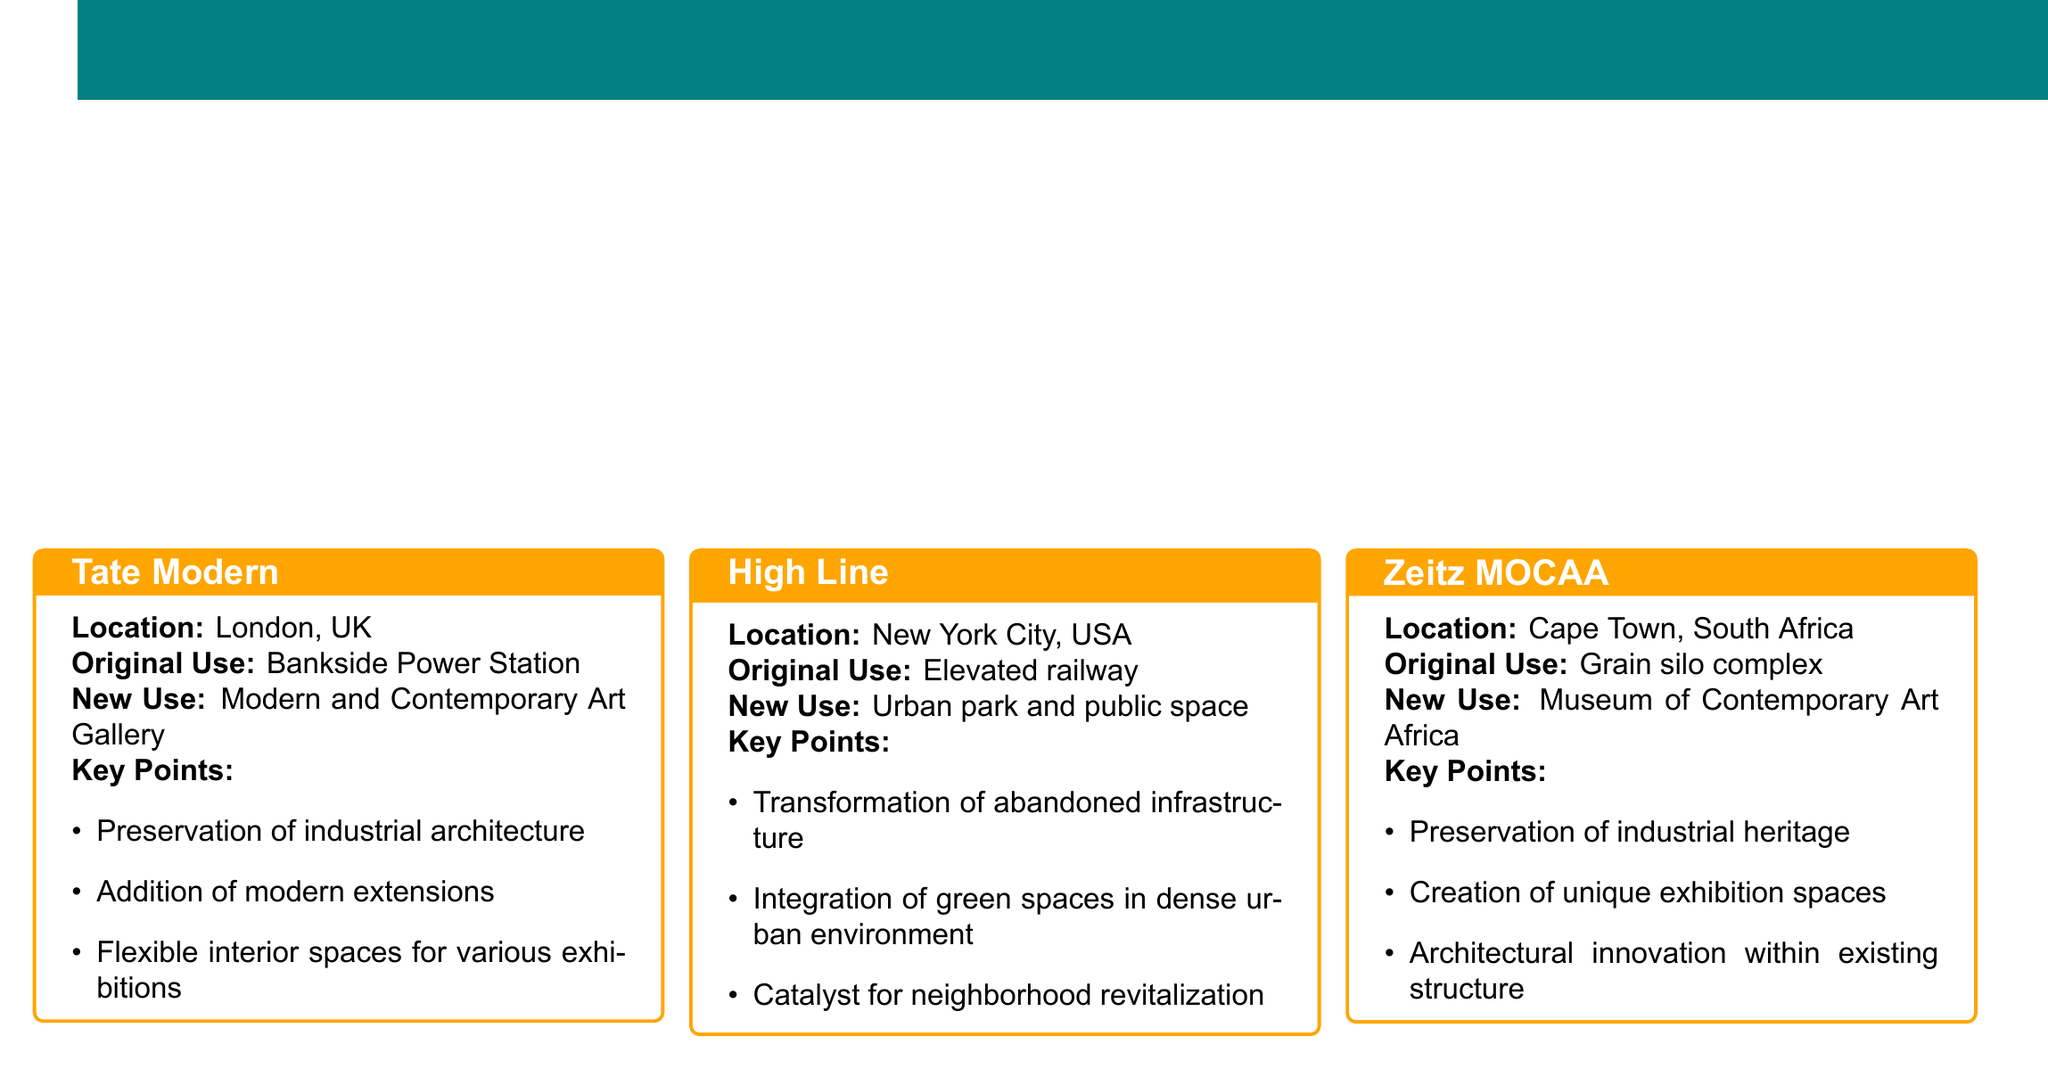what is the title of the document? The title of the document is presented at the top, highlighting the theme of the case studies.
Answer: Adaptive Reuse Success Stories what city is the Tate Modern located in? The document specifies the location of Tate Modern in London, UK.
Answer: London, UK what was the original use of the High Line? The original use of the High Line is described in its case study section.
Answer: Elevated railway what is the new use for the Zeitz MOCAA? The new use for the Zeitz MOCAA is indicated in its description.
Answer: Museum of Contemporary Art Africa how many key points are listed for the Tate Modern? The number of key points for the Tate Modern is counted in the document.
Answer: Three what architectural feature did the Zeitz MOCAA focus on? The document mentions a specific architectural feature emphasized in the new design of the Zeitz MOCAA.
Answer: Architectural innovation what does the conclusion of the document emphasize? The conclusion summarizes the overall message of the case studies presented.
Answer: Flexible zoning and building codes which adaptive reuse project serves as a catalyst for neighborhood revitalization? The document identifies a project that has played a significant role in revitalizing its surrounding area.
Answer: High Line 